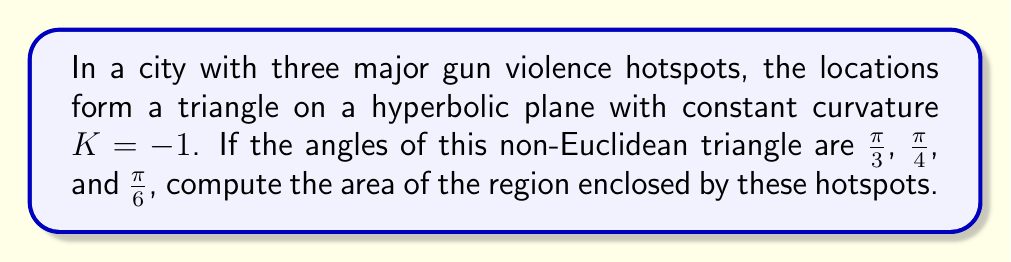Solve this math problem. To solve this problem, we'll use the Gauss-Bonnet formula for hyperbolic geometry:

$$A = (\alpha + \beta + \gamma - \pi) \cdot |K|^{-1}$$

Where:
- $A$ is the area of the hyperbolic triangle
- $\alpha$, $\beta$, and $\gamma$ are the angles of the triangle
- $K$ is the curvature of the hyperbolic plane

Given:
- $K = -1$
- $\alpha = \frac{\pi}{3}$
- $\beta = \frac{\pi}{4}$
- $\gamma = \frac{\pi}{6}$

Step 1: Sum the angles
$$\alpha + \beta + \gamma = \frac{\pi}{3} + \frac{\pi}{4} + \frac{\pi}{6} = \frac{4\pi}{12} + \frac{3\pi}{12} + \frac{2\pi}{12} = \frac{9\pi}{12} = \frac{3\pi}{4}$$

Step 2: Subtract $\pi$ from the sum of angles
$$(\alpha + \beta + \gamma - \pi) = \frac{3\pi}{4} - \pi = -\frac{\pi}{4}$$

Step 3: Apply the Gauss-Bonnet formula
$$A = (-\frac{\pi}{4}) \cdot |-1|^{-1} = \frac{\pi}{4}$$

Therefore, the area of the hyperbolic triangle formed by the three gun violence hotspots is $\frac{\pi}{4}$ square units.
Answer: $\frac{\pi}{4}$ square units 